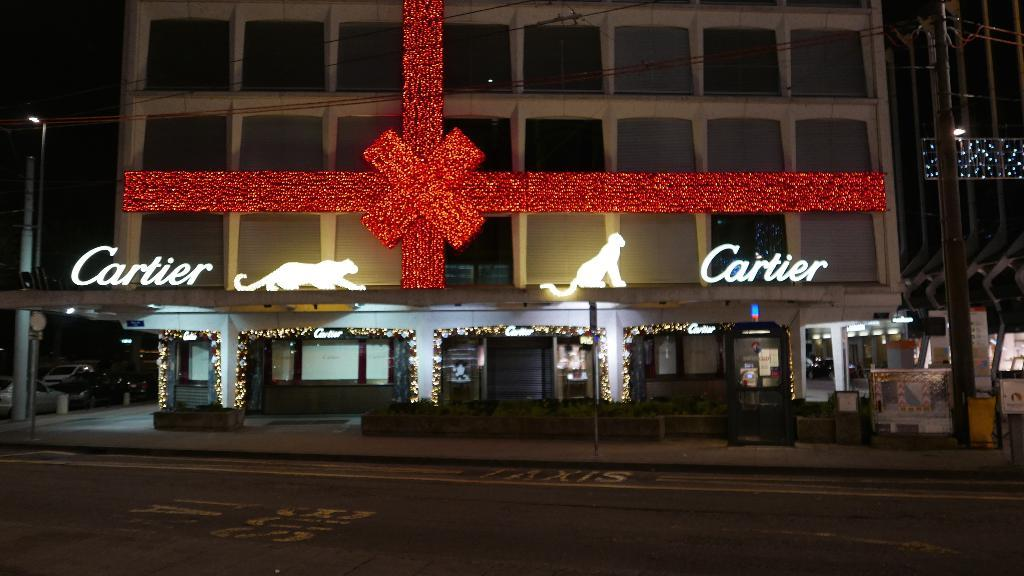What is the main feature of the image? There is a road in the image. What can be seen in the distance behind the road? There is a building, poles, lights, and some objects in the background of the image. What type of doll is present at the meeting in the image? There is no doll or meeting present in the image. Can you tell me what your uncle is doing in the image? There is no reference to an uncle or any person in the image. 